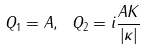Convert formula to latex. <formula><loc_0><loc_0><loc_500><loc_500>Q _ { 1 } = A , \ Q _ { 2 } = i \frac { A K } { \left | \kappa \right | }</formula> 